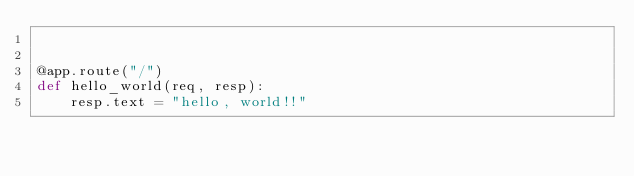<code> <loc_0><loc_0><loc_500><loc_500><_Python_>

@app.route("/")
def hello_world(req, resp):
    resp.text = "hello, world!!"
</code> 